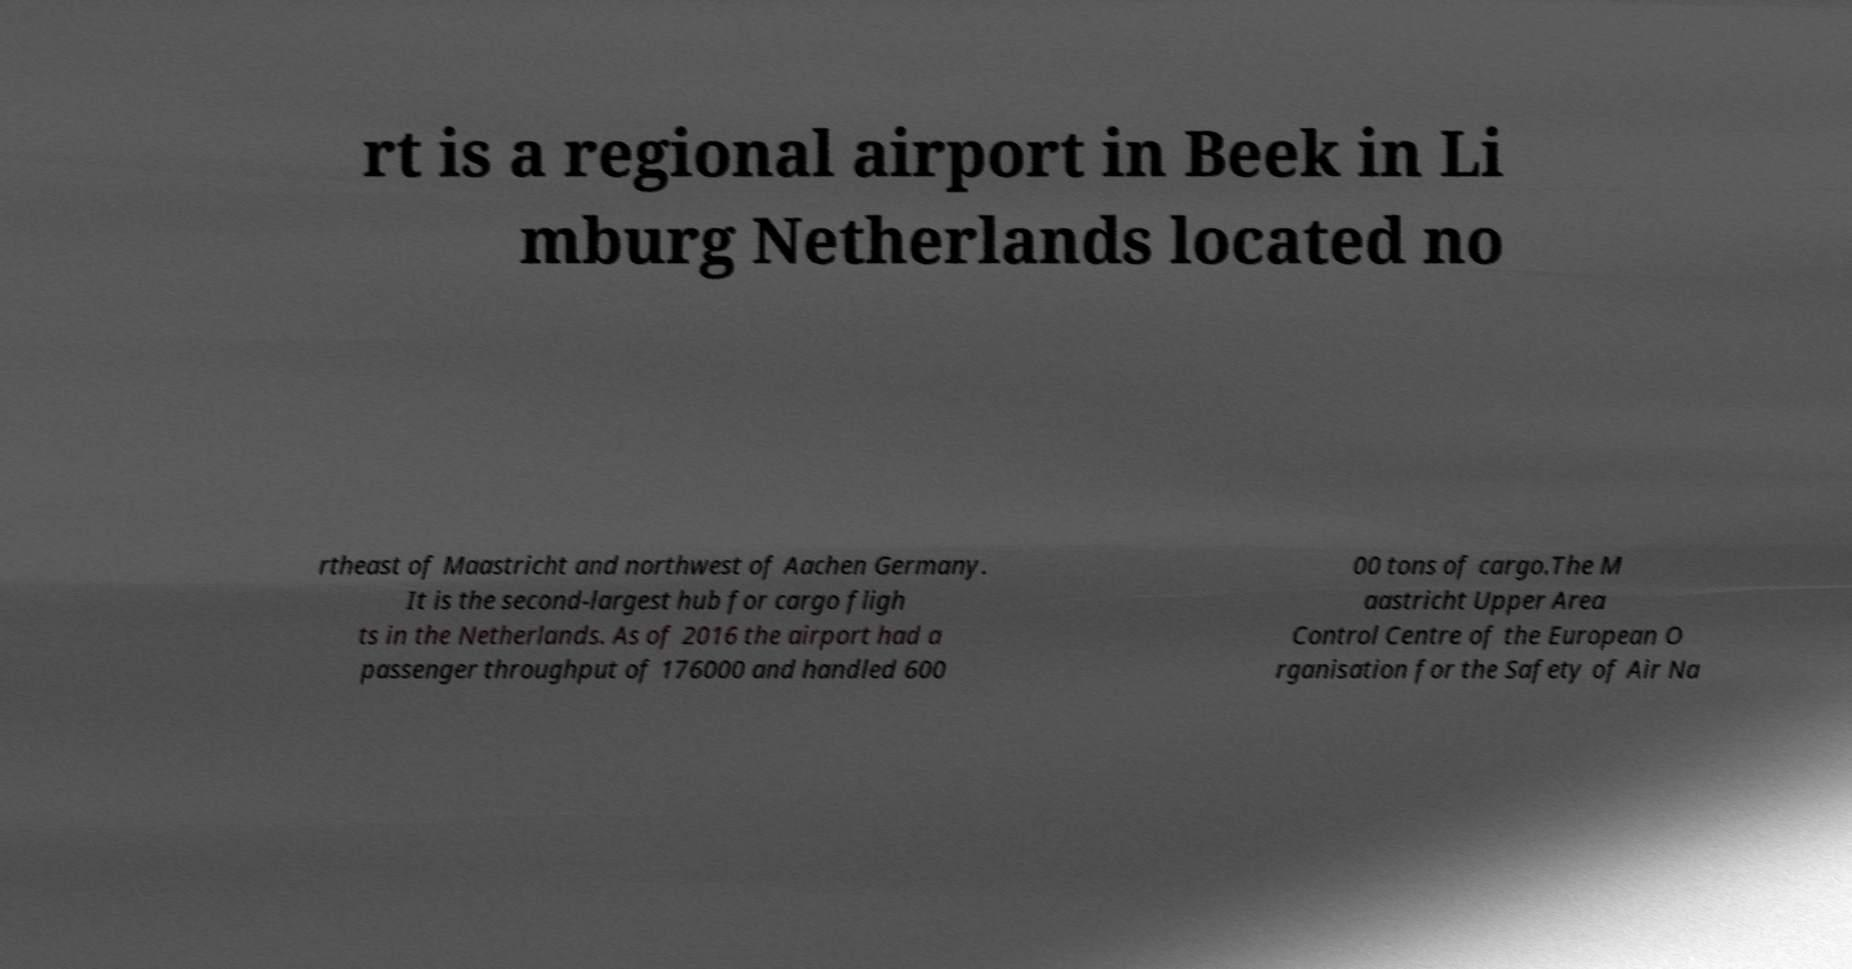Could you extract and type out the text from this image? rt is a regional airport in Beek in Li mburg Netherlands located no rtheast of Maastricht and northwest of Aachen Germany. It is the second-largest hub for cargo fligh ts in the Netherlands. As of 2016 the airport had a passenger throughput of 176000 and handled 600 00 tons of cargo.The M aastricht Upper Area Control Centre of the European O rganisation for the Safety of Air Na 